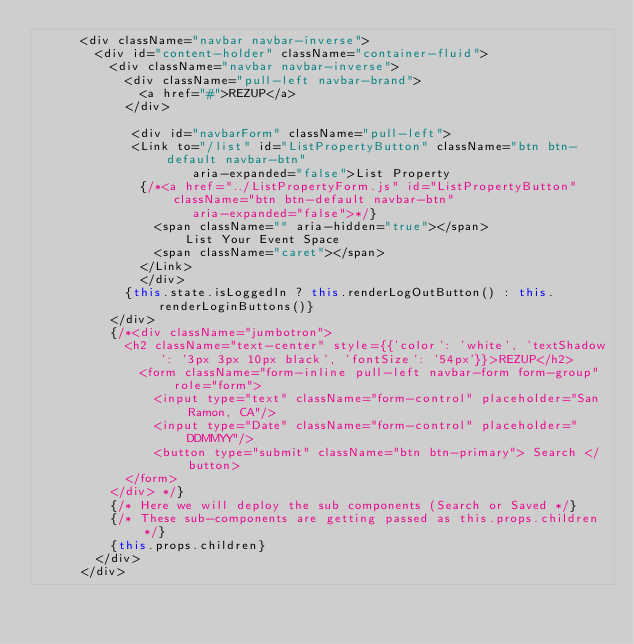Convert code to text. <code><loc_0><loc_0><loc_500><loc_500><_JavaScript_>      <div className="navbar navbar-inverse">
        <div id="content-holder" className="container-fluid">
          <div className="navbar navbar-inverse">
            <div className="pull-left navbar-brand">
              <a href="#">REZUP</a>
            </div>

             <div id="navbarForm" className="pull-left">
             <Link to="/list" id="ListPropertyButton" className="btn btn-default navbar-btn" 
                     aria-expanded="false">List Property
              {/*<a href="../ListPropertyForm.js" id="ListPropertyButton" className="btn btn-default navbar-btn" 
                     aria-expanded="false">*/}
                <span className="" aria-hidden="true"></span>
                    List Your Event Space
                <span className="caret"></span>
              </Link>
              </div>
            {this.state.isLoggedIn ? this.renderLogOutButton() : this.renderLoginButtons()}
          </div>
          {/*<div className="jumbotron">
            <h2 className="text-center" style={{'color': 'white', 'textShadow': '3px 3px 10px black', 'fontSize': '54px'}}>REZUP</h2>
              <form className="form-inline pull-left navbar-form form-group" role="form">
                <input type="text" className="form-control" placeholder="San Ramon, CA"/>
                <input type="Date" className="form-control" placeholder="DDMMYY"/>   
                <button type="submit" className="btn btn-primary"> Search </button>
            </form>
          </div> */}
          {/* Here we will deploy the sub components (Search or Saved */}
          {/* These sub-components are getting passed as this.props.children */}
          {this.props.children}
        </div>
      </div>   </code> 